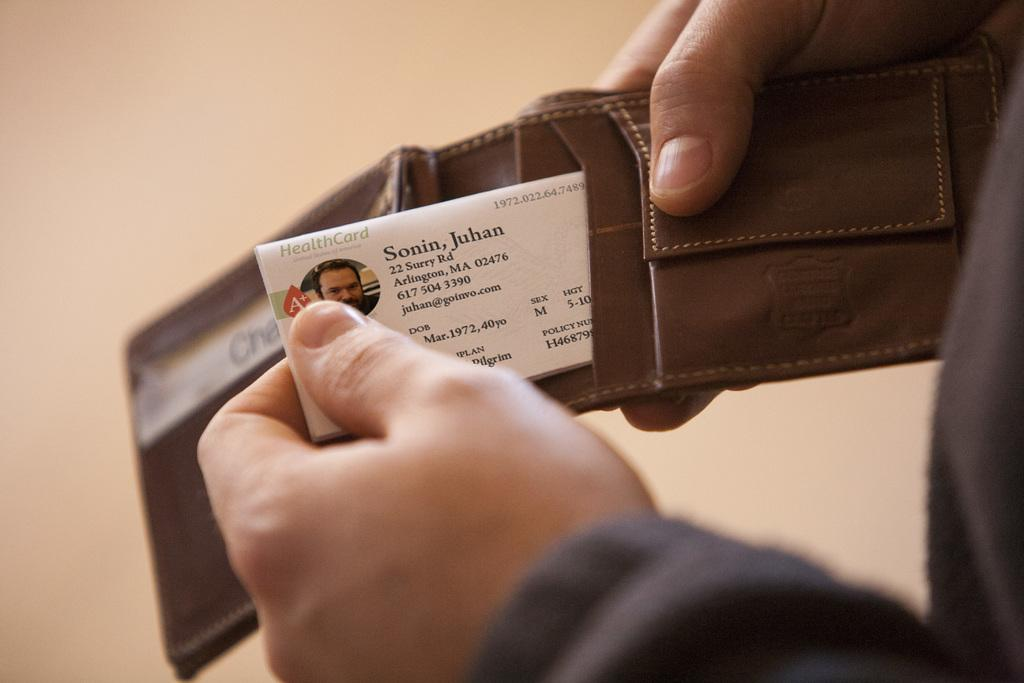What is being held by the hands in the image? There are hands holding a wallet in the image. What is inside the wallet that can be seen? There is a card in the hands. What can be seen in the background of the image? There is a wall in the background of the image. What type of pin can be seen on the grass in the image? There is no grass or pin present in the image. 